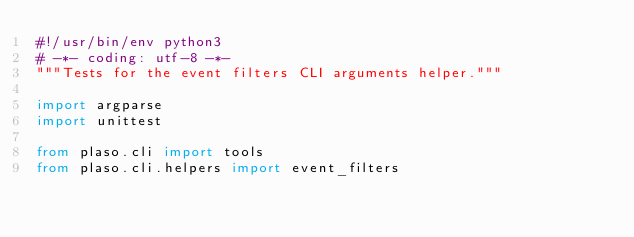<code> <loc_0><loc_0><loc_500><loc_500><_Python_>#!/usr/bin/env python3
# -*- coding: utf-8 -*-
"""Tests for the event filters CLI arguments helper."""

import argparse
import unittest

from plaso.cli import tools
from plaso.cli.helpers import event_filters</code> 